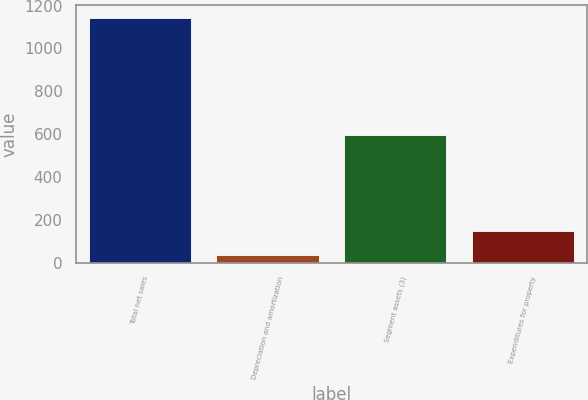Convert chart. <chart><loc_0><loc_0><loc_500><loc_500><bar_chart><fcel>Total net sales<fcel>Depreciation and amortization<fcel>Segment assets (3)<fcel>Expenditures for property<nl><fcel>1144<fcel>36<fcel>597<fcel>146.8<nl></chart> 